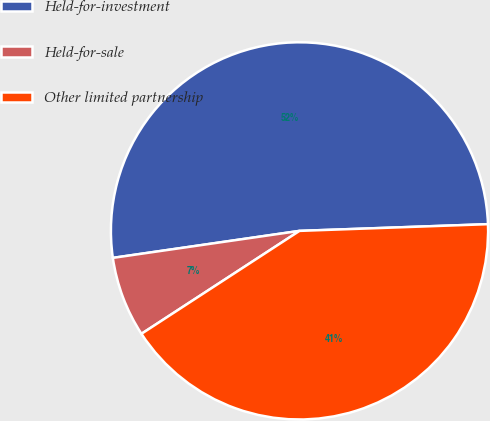<chart> <loc_0><loc_0><loc_500><loc_500><pie_chart><fcel>Held-for-investment<fcel>Held-for-sale<fcel>Other limited partnership<nl><fcel>51.72%<fcel>6.9%<fcel>41.38%<nl></chart> 